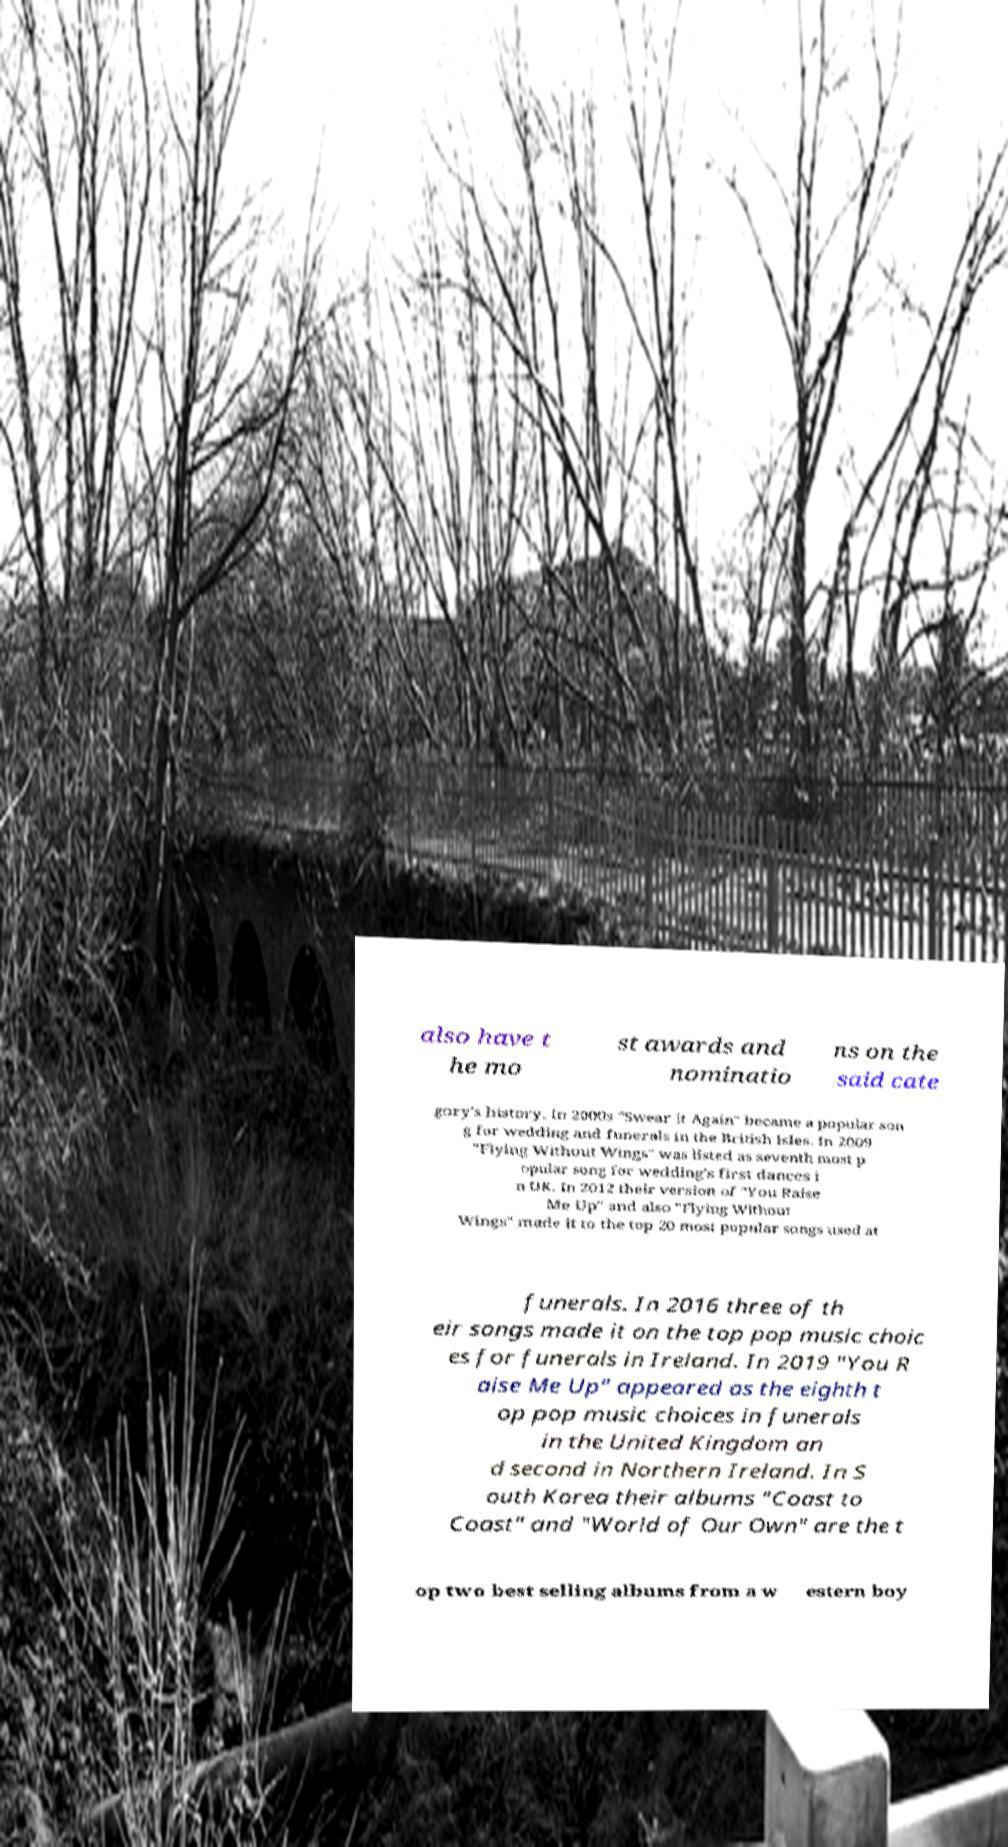I need the written content from this picture converted into text. Can you do that? also have t he mo st awards and nominatio ns on the said cate gory's history. In 2000s "Swear It Again" became a popular son g for wedding and funerals in the British Isles. In 2009 "Flying Without Wings" was listed as seventh most p opular song for wedding's first dances i n UK. In 2012 their version of "You Raise Me Up" and also "Flying Without Wings" made it to the top 20 most popular songs used at funerals. In 2016 three of th eir songs made it on the top pop music choic es for funerals in Ireland. In 2019 "You R aise Me Up" appeared as the eighth t op pop music choices in funerals in the United Kingdom an d second in Northern Ireland. In S outh Korea their albums "Coast to Coast" and "World of Our Own" are the t op two best selling albums from a w estern boy 